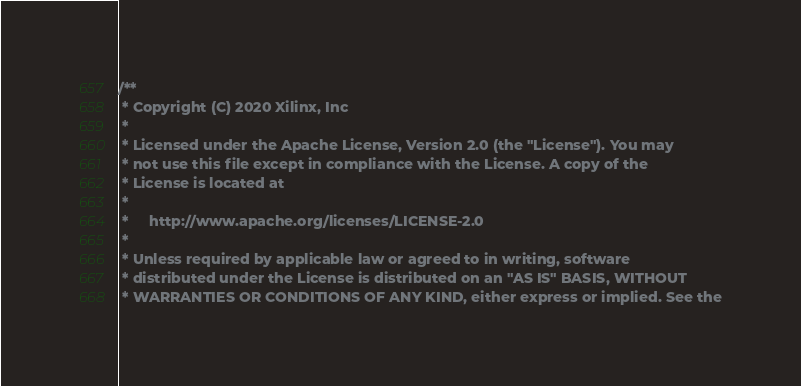<code> <loc_0><loc_0><loc_500><loc_500><_C++_>/**
 * Copyright (C) 2020 Xilinx, Inc
 *
 * Licensed under the Apache License, Version 2.0 (the "License"). You may
 * not use this file except in compliance with the License. A copy of the
 * License is located at
 *
 *     http://www.apache.org/licenses/LICENSE-2.0
 *
 * Unless required by applicable law or agreed to in writing, software
 * distributed under the License is distributed on an "AS IS" BASIS, WITHOUT
 * WARRANTIES OR CONDITIONS OF ANY KIND, either express or implied. See the</code> 